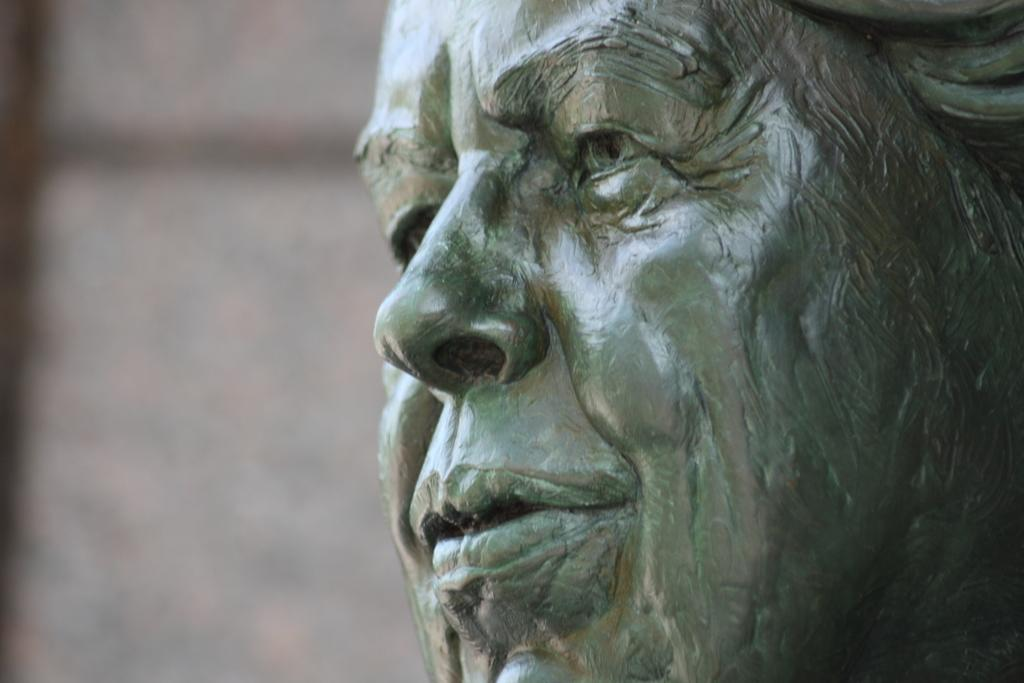What is located on the right side of the image? There is a statue of a person on the right side of the image. What colors are present on the left side of the image? There is a combination of white color and black color on the left side of the image. Where is the owl sitting in the image? There is no owl present in the image. What type of board is being used in the lunchroom in the image? There is no lunchroom or board present in the image. 